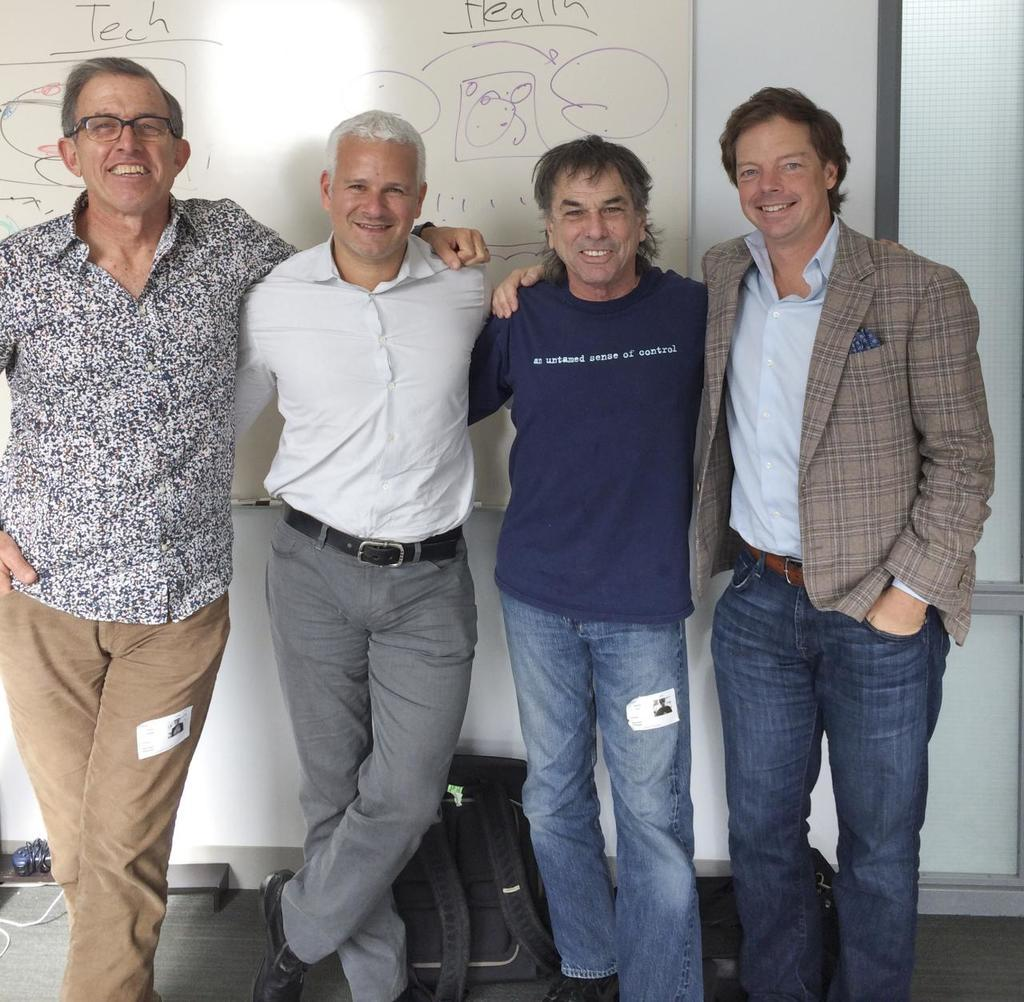Who or what can be seen in the image? There are people in the image. What else is present in the image besides the people? There are boards and objects on the ground in the image. What type of secretary can be seen working in the cemetery in the image? There is no secretary or cemetery present in the image; it features people, boards, and objects on the ground. 